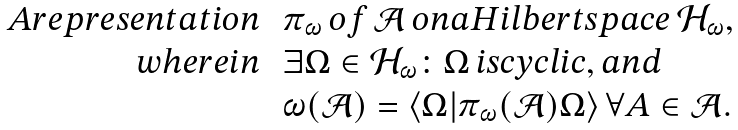Convert formula to latex. <formula><loc_0><loc_0><loc_500><loc_500>\begin{array} { r l } A r e p r e s e n t a t i o n & \, \pi _ { \omega } \, o f \, \mathcal { A } \, o n a H i l b e r t s p a c e \, \mathcal { H } _ { \omega } , \\ w h e r e i n & \, \exists \Omega \in \mathcal { H } _ { \omega } \colon \Omega \, i s c y c l i c , a n d \\ & \, \omega ( \mathcal { A } ) = \langle \Omega | \pi _ { \omega } ( \mathcal { A } ) \Omega \rangle \, \forall A \in \mathcal { A } . \end{array}</formula> 